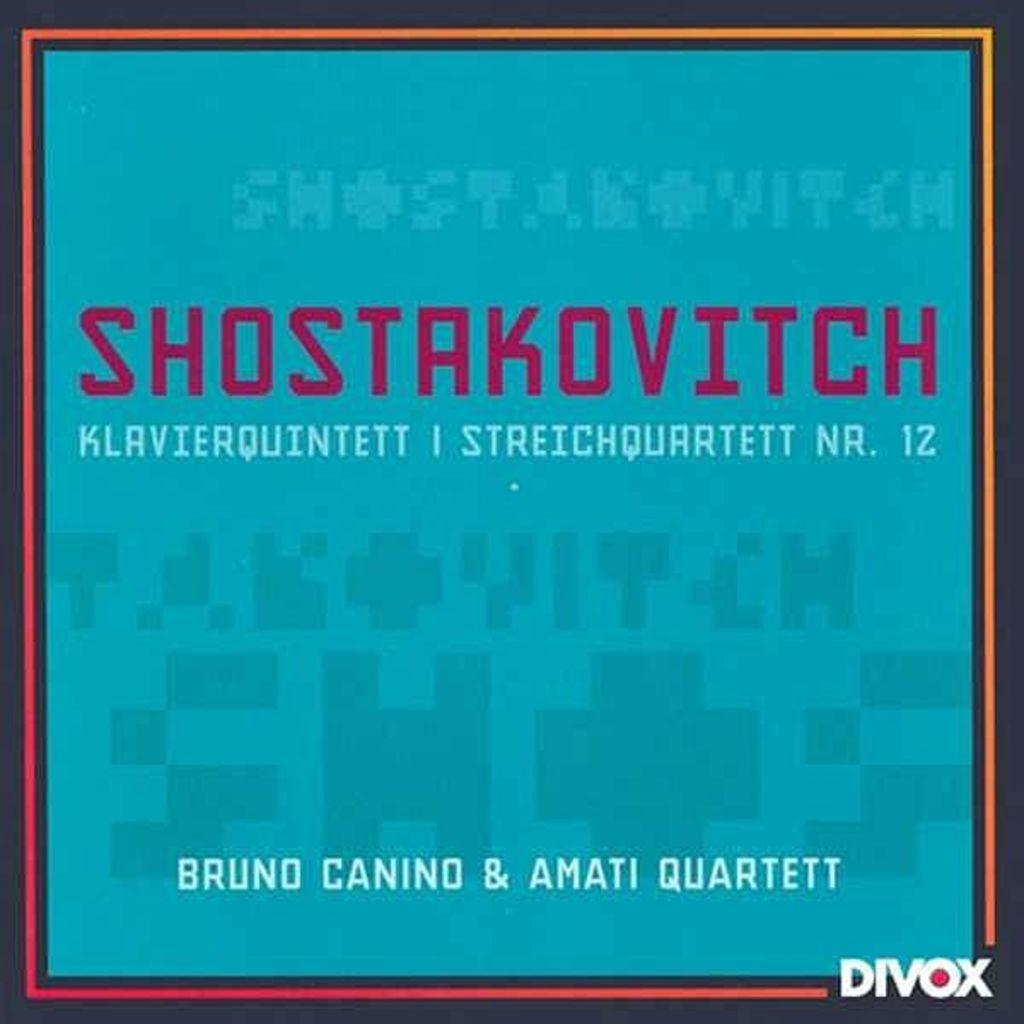<image>
Give a short and clear explanation of the subsequent image. ad for shostakovitch bruno canino display ad in blue 